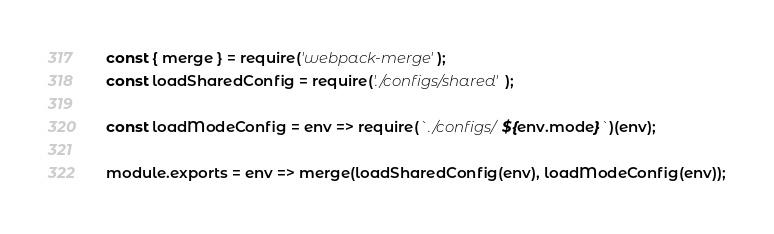<code> <loc_0><loc_0><loc_500><loc_500><_JavaScript_>const { merge } = require('webpack-merge');
const loadSharedConfig = require('./configs/shared');

const loadModeConfig = env => require(`./configs/${env.mode}`)(env);

module.exports = env => merge(loadSharedConfig(env), loadModeConfig(env));
</code> 